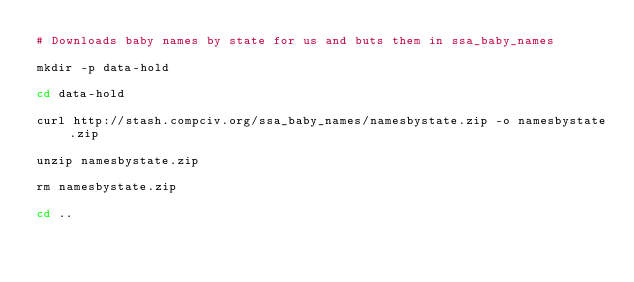<code> <loc_0><loc_0><loc_500><loc_500><_Bash_># Downloads baby names by state for us and buts them in ssa_baby_names

mkdir -p data-hold

cd data-hold

curl http://stash.compciv.org/ssa_baby_names/namesbystate.zip -o namesbystate.zip

unzip namesbystate.zip

rm namesbystate.zip

cd ..
</code> 